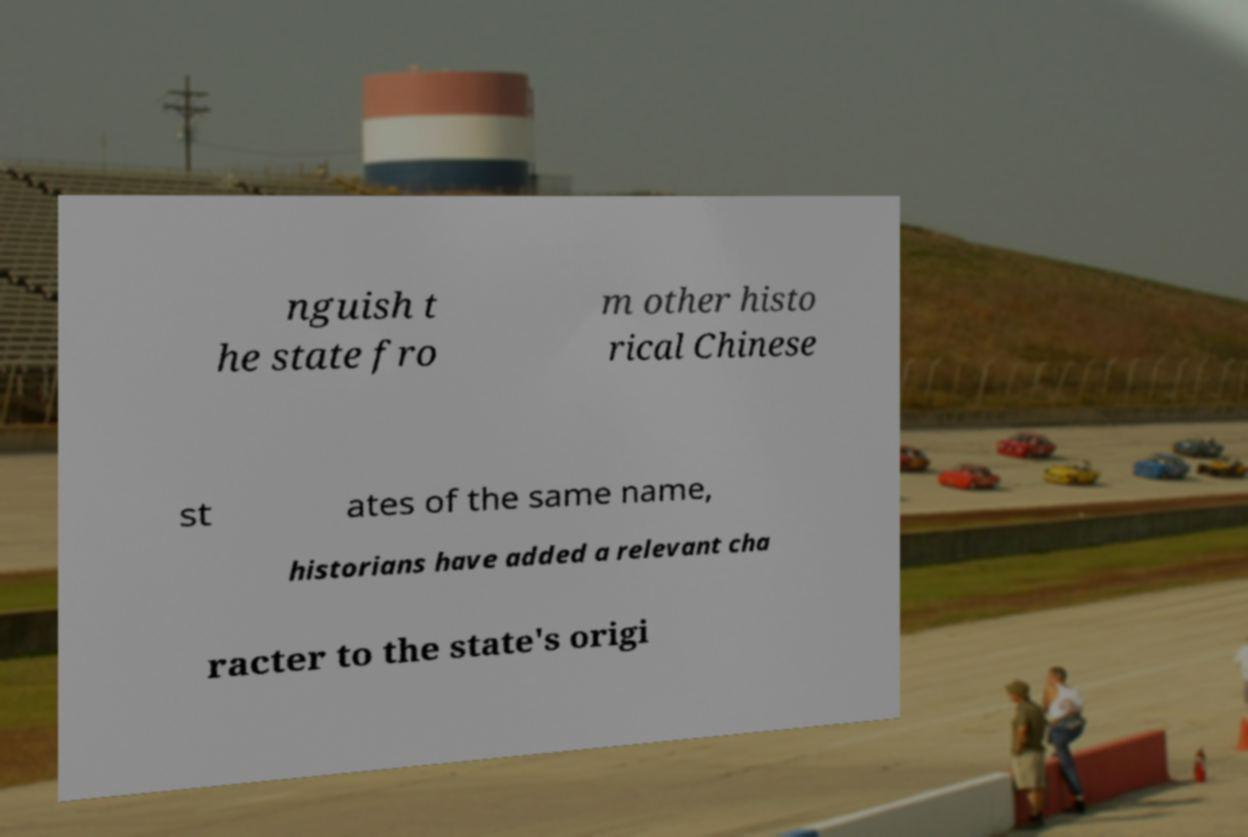Could you extract and type out the text from this image? nguish t he state fro m other histo rical Chinese st ates of the same name, historians have added a relevant cha racter to the state's origi 